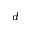Convert formula to latex. <formula><loc_0><loc_0><loc_500><loc_500>^ { d }</formula> 